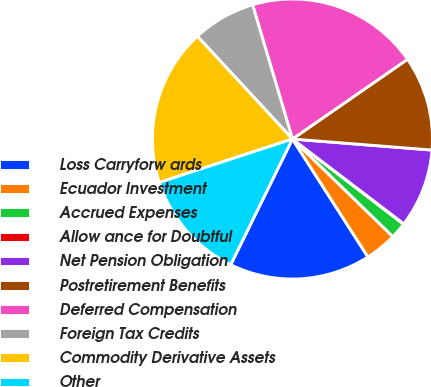<chart> <loc_0><loc_0><loc_500><loc_500><pie_chart><fcel>Loss Carryforw ards<fcel>Ecuador Investment<fcel>Accrued Expenses<fcel>Allow ance for Doubtful<fcel>Net Pension Obligation<fcel>Postretirement Benefits<fcel>Deferred Compensation<fcel>Foreign Tax Credits<fcel>Commodity Derivative Assets<fcel>Other<nl><fcel>16.33%<fcel>3.67%<fcel>1.86%<fcel>0.05%<fcel>9.1%<fcel>10.9%<fcel>19.95%<fcel>7.29%<fcel>18.14%<fcel>12.71%<nl></chart> 